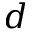<formula> <loc_0><loc_0><loc_500><loc_500>d</formula> 